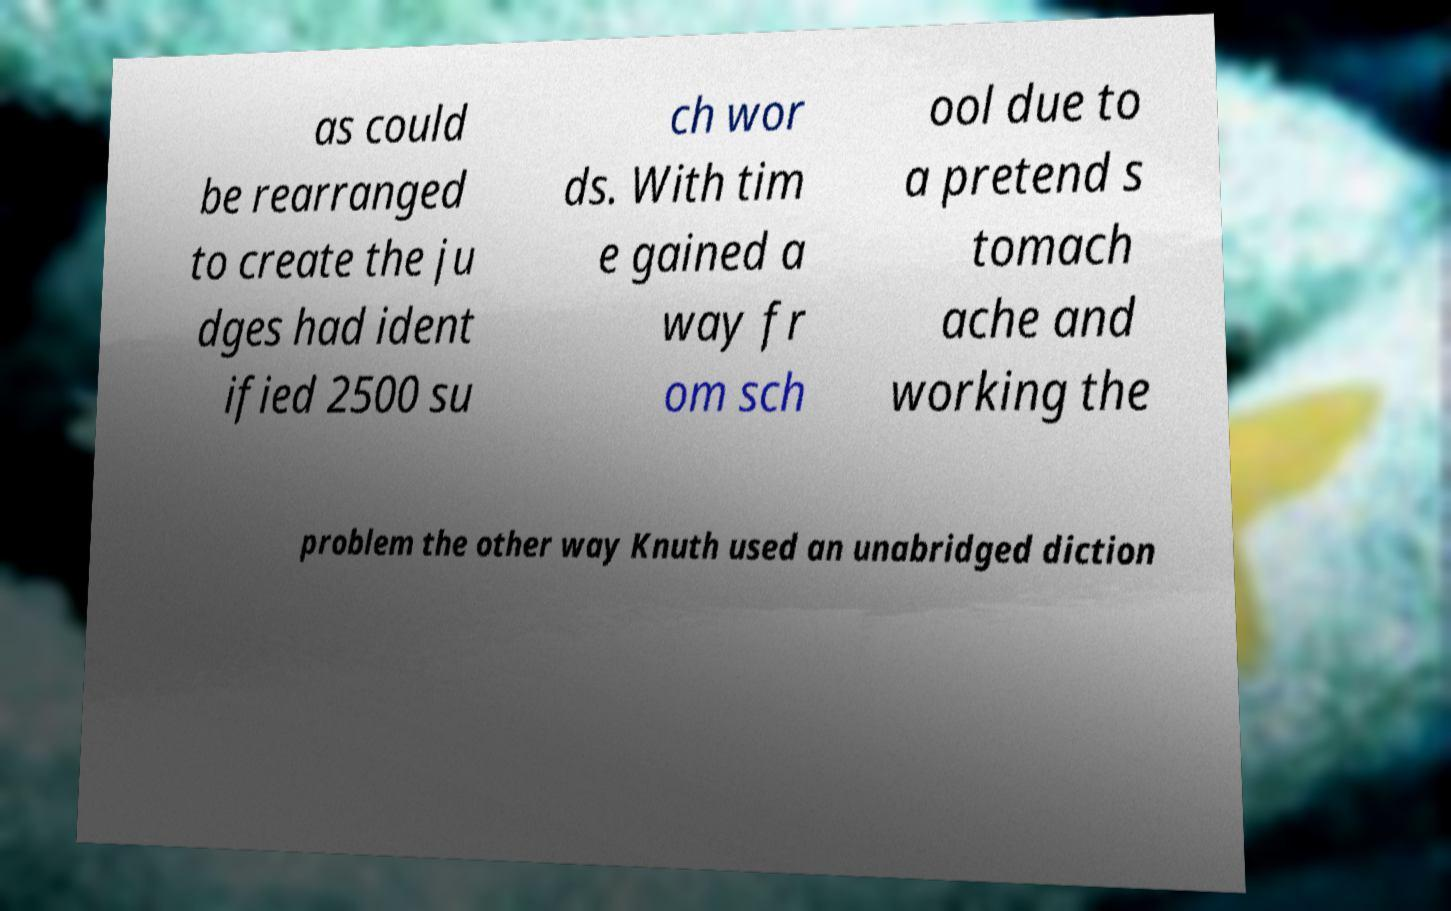For documentation purposes, I need the text within this image transcribed. Could you provide that? as could be rearranged to create the ju dges had ident ified 2500 su ch wor ds. With tim e gained a way fr om sch ool due to a pretend s tomach ache and working the problem the other way Knuth used an unabridged diction 